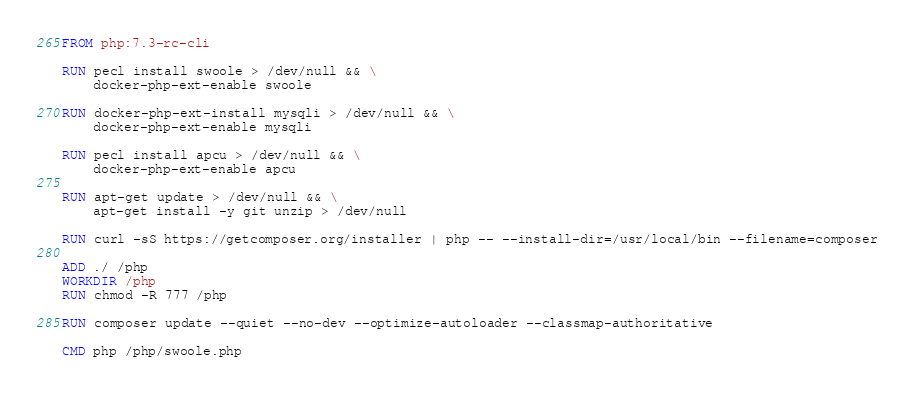<code> <loc_0><loc_0><loc_500><loc_500><_Dockerfile_>FROM php:7.3-rc-cli

RUN pecl install swoole > /dev/null && \
    docker-php-ext-enable swoole

RUN docker-php-ext-install mysqli > /dev/null && \
    docker-php-ext-enable mysqli

RUN pecl install apcu > /dev/null && \
    docker-php-ext-enable apcu

RUN apt-get update > /dev/null && \
    apt-get install -y git unzip > /dev/null

RUN curl -sS https://getcomposer.org/installer | php -- --install-dir=/usr/local/bin --filename=composer

ADD ./ /php
WORKDIR /php
RUN chmod -R 777 /php

RUN composer update --quiet --no-dev --optimize-autoloader --classmap-authoritative

CMD php /php/swoole.php
</code> 